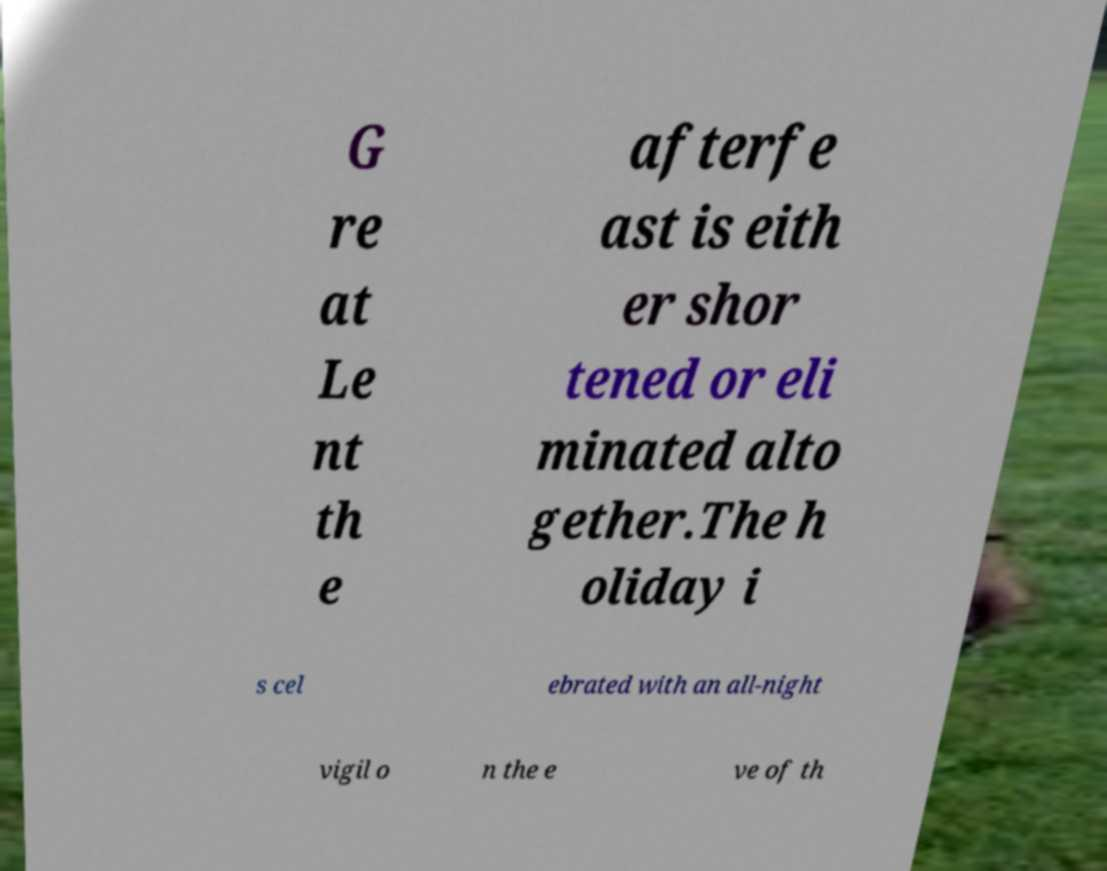Could you assist in decoding the text presented in this image and type it out clearly? G re at Le nt th e afterfe ast is eith er shor tened or eli minated alto gether.The h oliday i s cel ebrated with an all-night vigil o n the e ve of th 